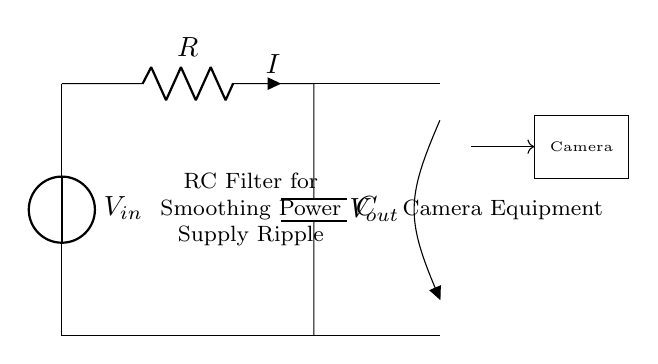What is the component labeled R in this circuit? The component labeled R is a resistor, which is designed to limit the current flowing through the circuit. Resistors are typically used to protect other components and control voltages.
Answer: Resistor What is the output voltage point in the circuit? The output voltage point, labeled as V out, is located at the open connection on the right side of the capacitor (C) and resistor (R). This is where the smoothed power supply voltage is taken for further use in the camera equipment.
Answer: V out What does the capacitor C do in this RC filter? The capacitor C stores charge and releases it to smooth out voltage variations. In an RC filter, it allows low-frequency signals to pass while reducing high-frequency noise, effectively filtering out ripple from the power supply provided to camera equipment.
Answer: Smooths voltage What is the purpose of using an RC filter in this circuit? The purpose of using an RC filter is to smooth power supply ripple, which helps provide a stable voltage to the camera equipment. The filter absorbs fluctuations in the input voltage and maintains smoother output.
Answer: Smoothing ripple What is the relationship between resistance and smoothing effectiveness in this circuit? The resistance value affects the time constant of the RC circuit, which determines how quickly the capacitor charges and discharges. A higher resistance leads to slower charging, enhancing smoothing, while a lower resistance reduces the smoothness. Thus, optimal resistance is crucial for effective smoothing.
Answer: Time constant How can you increase the smoothing effect of the RC filter? To increase the smoothing effect of the RC filter, you can either increase the capacitance (C) or the resistance (R). Increasing capacitance allows for greater charge storage, while increased resistance extends the time constant, both contributing to better voltage stabilization.
Answer: Increase C or R 